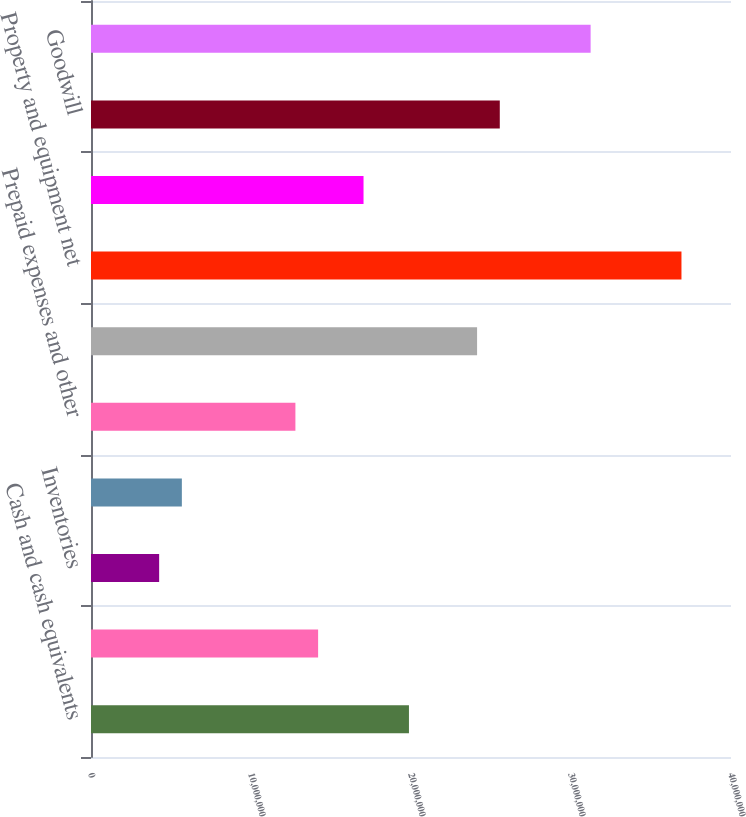<chart> <loc_0><loc_0><loc_500><loc_500><bar_chart><fcel>Cash and cash equivalents<fcel>Accounts receivable net<fcel>Inventories<fcel>Deferred income taxes net<fcel>Prepaid expenses and other<fcel>Total current assets<fcel>Property and equipment net<fcel>Investments in and advances to<fcel>Goodwill<fcel>Other intangible assets net<nl><fcel>1.9872e+07<fcel>1.41947e+07<fcel>4.25934e+06<fcel>5.67867e+06<fcel>1.27753e+07<fcel>2.413e+07<fcel>3.69039e+07<fcel>1.70333e+07<fcel>2.55493e+07<fcel>3.12266e+07<nl></chart> 